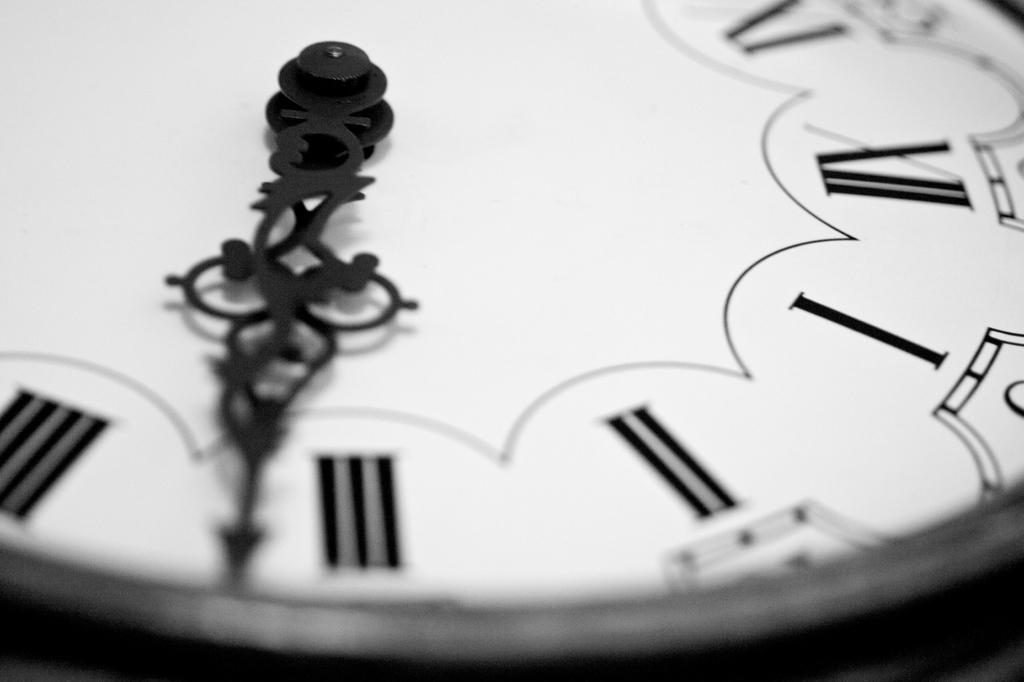Provide a one-sentence caption for the provided image. A black and white close up of portion of a clock shows both hands almost half past three. 